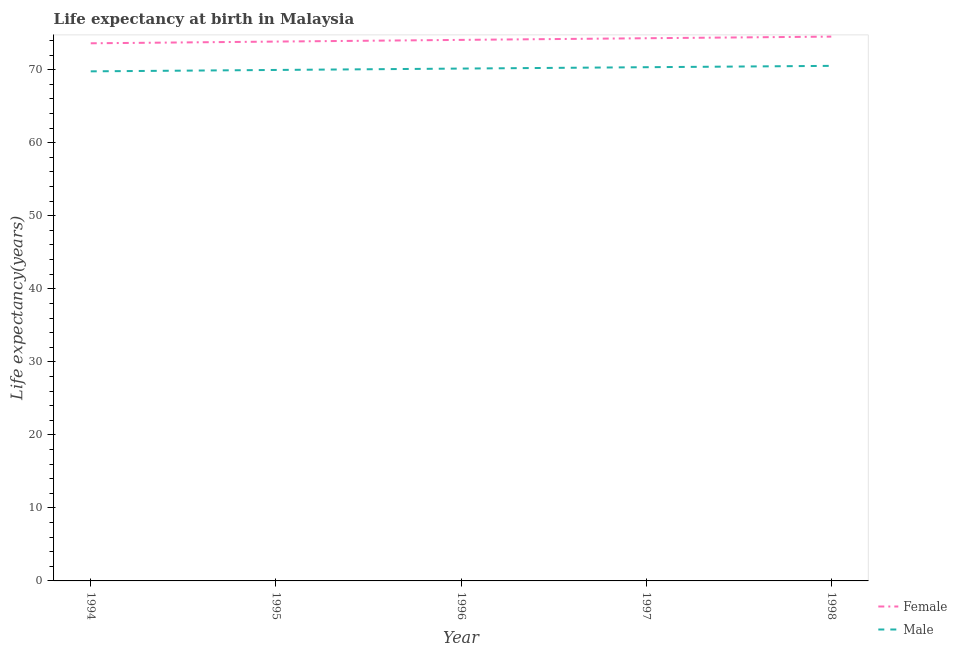How many different coloured lines are there?
Keep it short and to the point. 2. What is the life expectancy(male) in 1997?
Make the answer very short. 70.34. Across all years, what is the maximum life expectancy(male)?
Offer a very short reply. 70.53. Across all years, what is the minimum life expectancy(male)?
Give a very brief answer. 69.78. In which year was the life expectancy(male) maximum?
Provide a succinct answer. 1998. In which year was the life expectancy(male) minimum?
Your answer should be compact. 1994. What is the total life expectancy(male) in the graph?
Make the answer very short. 350.77. What is the difference between the life expectancy(male) in 1994 and that in 1997?
Make the answer very short. -0.57. What is the difference between the life expectancy(female) in 1997 and the life expectancy(male) in 1996?
Your response must be concise. 4.15. What is the average life expectancy(female) per year?
Your answer should be very brief. 74.08. In the year 1998, what is the difference between the life expectancy(female) and life expectancy(male)?
Your answer should be compact. 4. What is the ratio of the life expectancy(female) in 1994 to that in 1995?
Offer a very short reply. 1. Is the life expectancy(male) in 1994 less than that in 1998?
Your response must be concise. Yes. Is the difference between the life expectancy(female) in 1994 and 1996 greater than the difference between the life expectancy(male) in 1994 and 1996?
Ensure brevity in your answer.  No. What is the difference between the highest and the second highest life expectancy(female)?
Offer a very short reply. 0.22. What is the difference between the highest and the lowest life expectancy(male)?
Provide a succinct answer. 0.75. In how many years, is the life expectancy(female) greater than the average life expectancy(female) taken over all years?
Ensure brevity in your answer.  3. How many lines are there?
Your answer should be very brief. 2. Are the values on the major ticks of Y-axis written in scientific E-notation?
Offer a terse response. No. Does the graph contain grids?
Your response must be concise. No. Where does the legend appear in the graph?
Your response must be concise. Bottom right. What is the title of the graph?
Your answer should be very brief. Life expectancy at birth in Malaysia. What is the label or title of the X-axis?
Your answer should be compact. Year. What is the label or title of the Y-axis?
Give a very brief answer. Life expectancy(years). What is the Life expectancy(years) in Female in 1994?
Ensure brevity in your answer.  73.62. What is the Life expectancy(years) of Male in 1994?
Your response must be concise. 69.78. What is the Life expectancy(years) in Female in 1995?
Offer a terse response. 73.85. What is the Life expectancy(years) of Male in 1995?
Offer a very short reply. 69.97. What is the Life expectancy(years) in Female in 1996?
Make the answer very short. 74.08. What is the Life expectancy(years) in Male in 1996?
Keep it short and to the point. 70.16. What is the Life expectancy(years) in Female in 1997?
Your response must be concise. 74.31. What is the Life expectancy(years) in Male in 1997?
Your response must be concise. 70.34. What is the Life expectancy(years) of Female in 1998?
Your answer should be compact. 74.53. What is the Life expectancy(years) of Male in 1998?
Keep it short and to the point. 70.53. Across all years, what is the maximum Life expectancy(years) of Female?
Offer a terse response. 74.53. Across all years, what is the maximum Life expectancy(years) in Male?
Give a very brief answer. 70.53. Across all years, what is the minimum Life expectancy(years) of Female?
Give a very brief answer. 73.62. Across all years, what is the minimum Life expectancy(years) in Male?
Give a very brief answer. 69.78. What is the total Life expectancy(years) of Female in the graph?
Ensure brevity in your answer.  370.4. What is the total Life expectancy(years) in Male in the graph?
Give a very brief answer. 350.77. What is the difference between the Life expectancy(years) in Female in 1994 and that in 1995?
Make the answer very short. -0.23. What is the difference between the Life expectancy(years) of Male in 1994 and that in 1995?
Make the answer very short. -0.19. What is the difference between the Life expectancy(years) in Female in 1994 and that in 1996?
Your answer should be very brief. -0.47. What is the difference between the Life expectancy(years) of Male in 1994 and that in 1996?
Your answer should be compact. -0.38. What is the difference between the Life expectancy(years) in Female in 1994 and that in 1997?
Your answer should be compact. -0.69. What is the difference between the Life expectancy(years) of Male in 1994 and that in 1997?
Provide a succinct answer. -0.57. What is the difference between the Life expectancy(years) of Female in 1994 and that in 1998?
Ensure brevity in your answer.  -0.92. What is the difference between the Life expectancy(years) of Male in 1994 and that in 1998?
Your response must be concise. -0.75. What is the difference between the Life expectancy(years) in Female in 1995 and that in 1996?
Give a very brief answer. -0.23. What is the difference between the Life expectancy(years) in Male in 1995 and that in 1996?
Offer a terse response. -0.19. What is the difference between the Life expectancy(years) of Female in 1995 and that in 1997?
Offer a very short reply. -0.46. What is the difference between the Life expectancy(years) of Male in 1995 and that in 1997?
Offer a very short reply. -0.38. What is the difference between the Life expectancy(years) in Female in 1995 and that in 1998?
Your response must be concise. -0.68. What is the difference between the Life expectancy(years) in Male in 1995 and that in 1998?
Give a very brief answer. -0.56. What is the difference between the Life expectancy(years) in Female in 1996 and that in 1997?
Give a very brief answer. -0.23. What is the difference between the Life expectancy(years) in Male in 1996 and that in 1997?
Provide a short and direct response. -0.19. What is the difference between the Life expectancy(years) of Female in 1996 and that in 1998?
Your answer should be compact. -0.45. What is the difference between the Life expectancy(years) of Male in 1996 and that in 1998?
Ensure brevity in your answer.  -0.37. What is the difference between the Life expectancy(years) in Female in 1997 and that in 1998?
Give a very brief answer. -0.22. What is the difference between the Life expectancy(years) of Male in 1997 and that in 1998?
Give a very brief answer. -0.18. What is the difference between the Life expectancy(years) of Female in 1994 and the Life expectancy(years) of Male in 1995?
Your response must be concise. 3.65. What is the difference between the Life expectancy(years) of Female in 1994 and the Life expectancy(years) of Male in 1996?
Provide a short and direct response. 3.46. What is the difference between the Life expectancy(years) in Female in 1994 and the Life expectancy(years) in Male in 1997?
Your answer should be compact. 3.27. What is the difference between the Life expectancy(years) of Female in 1994 and the Life expectancy(years) of Male in 1998?
Offer a very short reply. 3.09. What is the difference between the Life expectancy(years) of Female in 1995 and the Life expectancy(years) of Male in 1996?
Provide a short and direct response. 3.7. What is the difference between the Life expectancy(years) in Female in 1995 and the Life expectancy(years) in Male in 1997?
Provide a short and direct response. 3.51. What is the difference between the Life expectancy(years) of Female in 1995 and the Life expectancy(years) of Male in 1998?
Your answer should be compact. 3.33. What is the difference between the Life expectancy(years) of Female in 1996 and the Life expectancy(years) of Male in 1997?
Your answer should be compact. 3.74. What is the difference between the Life expectancy(years) in Female in 1996 and the Life expectancy(years) in Male in 1998?
Give a very brief answer. 3.56. What is the difference between the Life expectancy(years) in Female in 1997 and the Life expectancy(years) in Male in 1998?
Offer a terse response. 3.78. What is the average Life expectancy(years) in Female per year?
Make the answer very short. 74.08. What is the average Life expectancy(years) in Male per year?
Keep it short and to the point. 70.15. In the year 1994, what is the difference between the Life expectancy(years) of Female and Life expectancy(years) of Male?
Offer a very short reply. 3.84. In the year 1995, what is the difference between the Life expectancy(years) in Female and Life expectancy(years) in Male?
Your answer should be compact. 3.88. In the year 1996, what is the difference between the Life expectancy(years) in Female and Life expectancy(years) in Male?
Provide a short and direct response. 3.93. In the year 1997, what is the difference between the Life expectancy(years) in Female and Life expectancy(years) in Male?
Your answer should be compact. 3.97. In the year 1998, what is the difference between the Life expectancy(years) of Female and Life expectancy(years) of Male?
Your response must be concise. 4. What is the ratio of the Life expectancy(years) in Female in 1994 to that in 1995?
Your answer should be compact. 1. What is the ratio of the Life expectancy(years) in Male in 1994 to that in 1995?
Offer a very short reply. 1. What is the ratio of the Life expectancy(years) in Female in 1994 to that in 1996?
Keep it short and to the point. 0.99. What is the ratio of the Life expectancy(years) of Male in 1994 to that in 1998?
Offer a terse response. 0.99. What is the ratio of the Life expectancy(years) of Female in 1995 to that in 1996?
Keep it short and to the point. 1. What is the ratio of the Life expectancy(years) in Female in 1995 to that in 1998?
Your response must be concise. 0.99. What is the ratio of the Life expectancy(years) of Male in 1996 to that in 1997?
Give a very brief answer. 1. What is the difference between the highest and the second highest Life expectancy(years) in Female?
Ensure brevity in your answer.  0.22. What is the difference between the highest and the second highest Life expectancy(years) in Male?
Provide a short and direct response. 0.18. What is the difference between the highest and the lowest Life expectancy(years) in Female?
Offer a very short reply. 0.92. What is the difference between the highest and the lowest Life expectancy(years) in Male?
Offer a terse response. 0.75. 